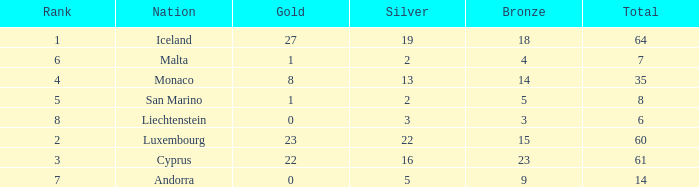Could you parse the entire table? {'header': ['Rank', 'Nation', 'Gold', 'Silver', 'Bronze', 'Total'], 'rows': [['1', 'Iceland', '27', '19', '18', '64'], ['6', 'Malta', '1', '2', '4', '7'], ['4', 'Monaco', '8', '13', '14', '35'], ['5', 'San Marino', '1', '2', '5', '8'], ['8', 'Liechtenstein', '0', '3', '3', '6'], ['2', 'Luxembourg', '23', '22', '15', '60'], ['3', 'Cyprus', '22', '16', '23', '61'], ['7', 'Andorra', '0', '5', '9', '14']]} How many golds for the nation with 14 total? 0.0. 